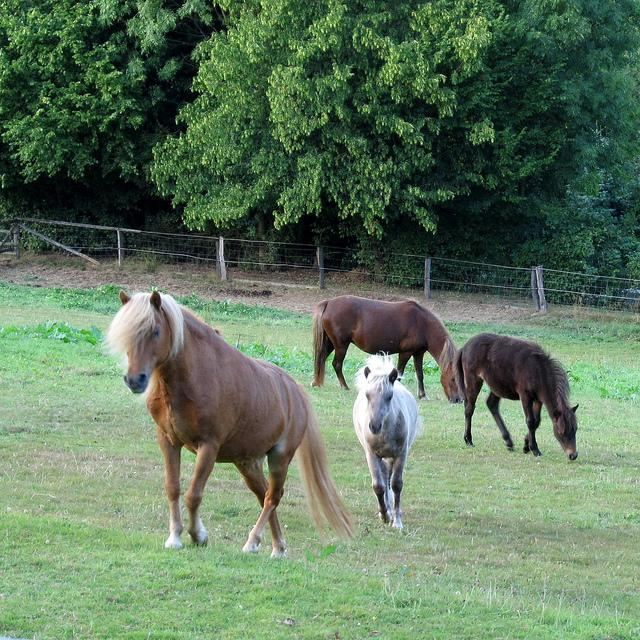What animals are present? Please explain your reasoning. horse. These are horses in the field. 